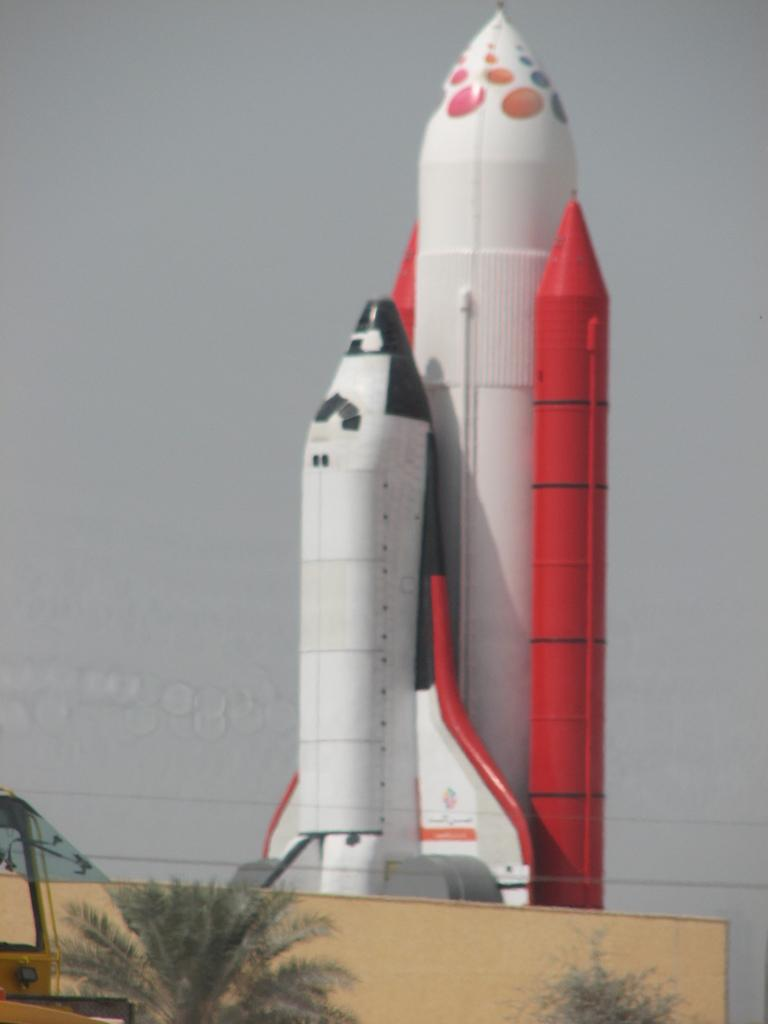What is the main subject in the center of the image? There is an airplane in the center of the image. What can be seen at the bottom of the image? There is a wall and trees at the bottom of the image, as well as a vehicle. What is visible in the background of the image? The sky is visible in the background of the image. Can you see a girl sneezing on the table in the image? There is no girl or table present in the image, and therefore no sneezing can be observed. 